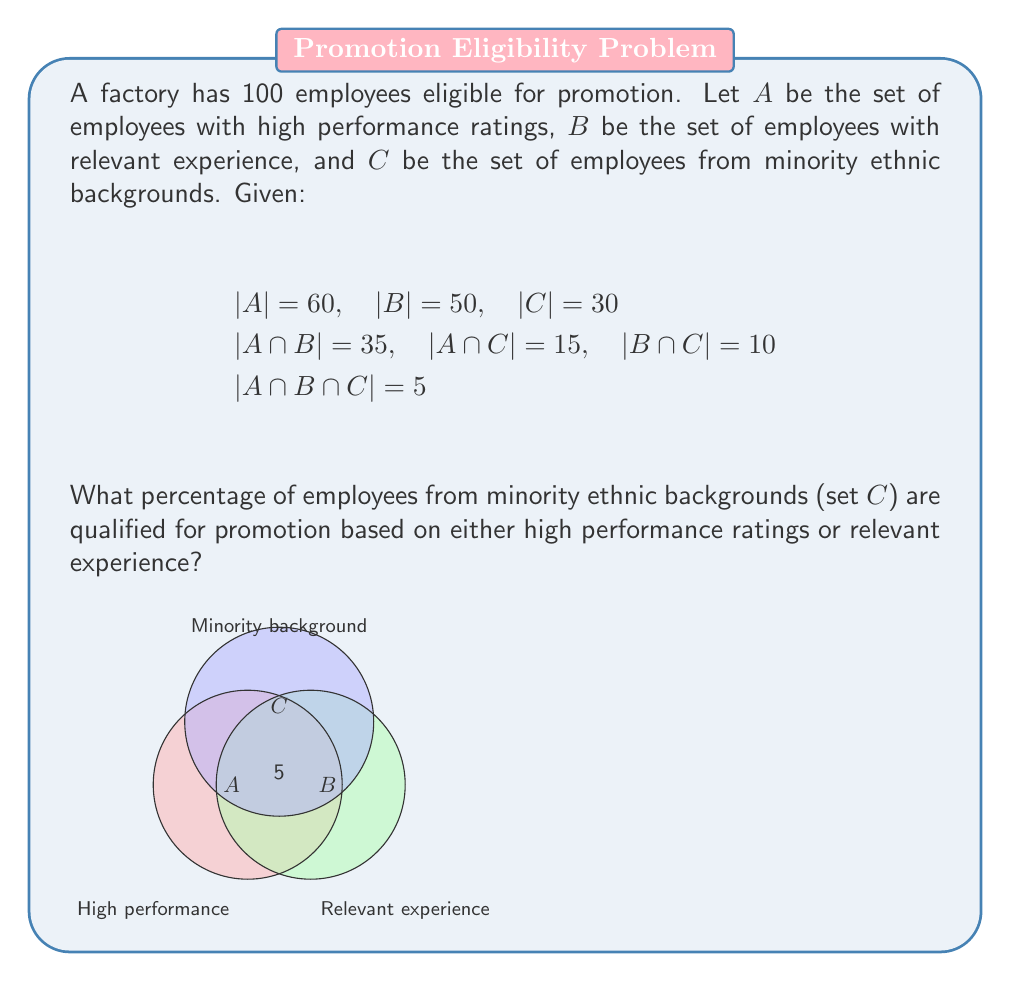Can you answer this question? Let's approach this step-by-step:

1) We need to find $(A \cup B) \cap C$, which represents minority employees who are qualified based on either high performance or relevant experience.

2) First, let's find $|A \cup B|$ using the inclusion-exclusion principle:
   $|A \cup B| = |A| + |B| - |A \cap B| = 60 + 50 - 35 = 75$

3) Now, we need to find $|(A \cup B) \cap C|$. We can use the formula:
   $|(A \cup B) \cap C| = |A \cap C| + |B \cap C| - |A \cap B \cap C|$

4) We're given these values:
   $|A \cap C| = 15$
   $|B \cap C| = 10$
   $|A \cap B \cap C| = 5$

5) Plugging in:
   $|(A \cup B) \cap C| = 15 + 10 - 5 = 20$

6) To get the percentage, we divide by the total number in set C and multiply by 100:
   $\frac{20}{30} \times 100 = \frac{2}{3} \times 100 \approx 66.67\%$
Answer: $66.67\%$ 